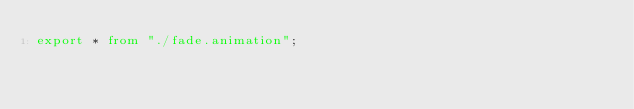<code> <loc_0><loc_0><loc_500><loc_500><_TypeScript_>export * from "./fade.animation";
</code> 